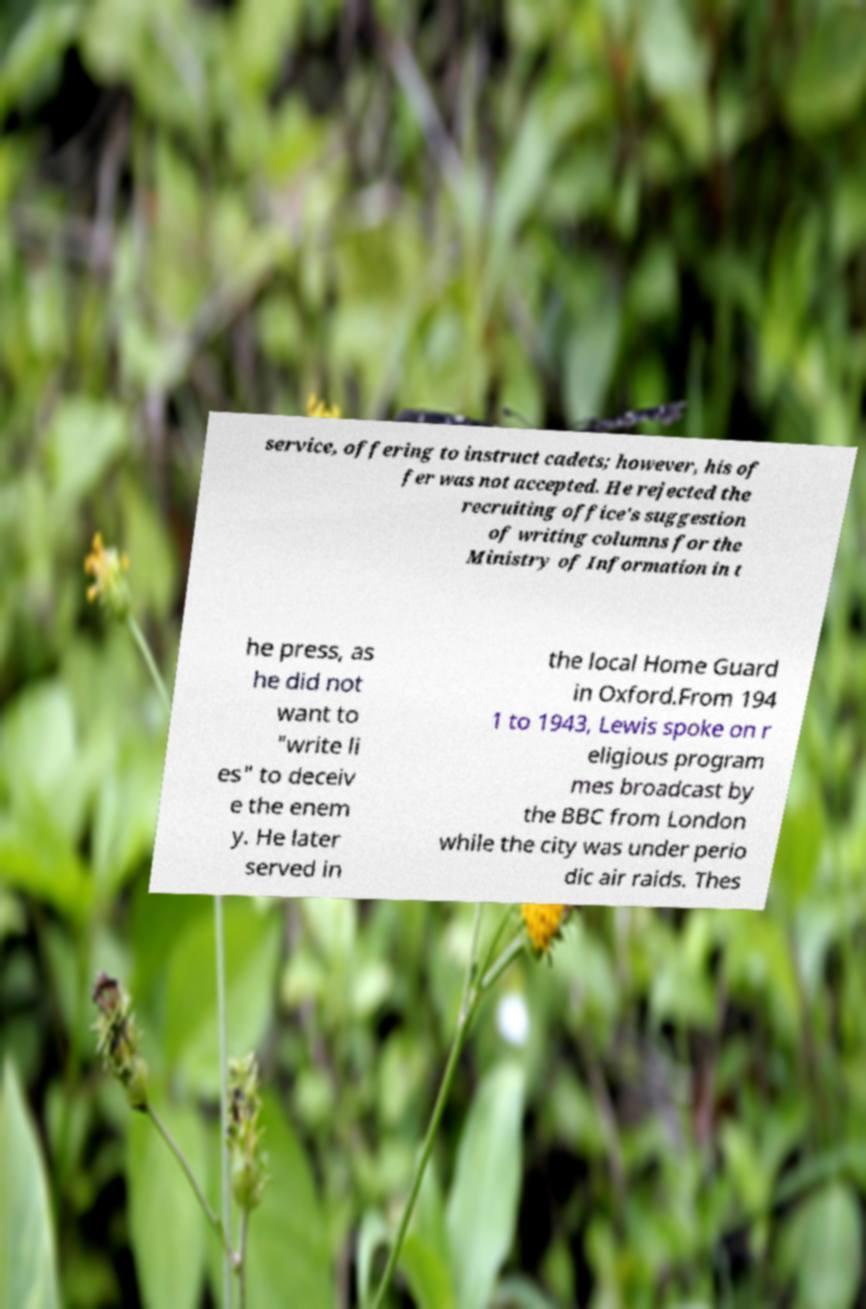What messages or text are displayed in this image? I need them in a readable, typed format. service, offering to instruct cadets; however, his of fer was not accepted. He rejected the recruiting office's suggestion of writing columns for the Ministry of Information in t he press, as he did not want to "write li es" to deceiv e the enem y. He later served in the local Home Guard in Oxford.From 194 1 to 1943, Lewis spoke on r eligious program mes broadcast by the BBC from London while the city was under perio dic air raids. Thes 